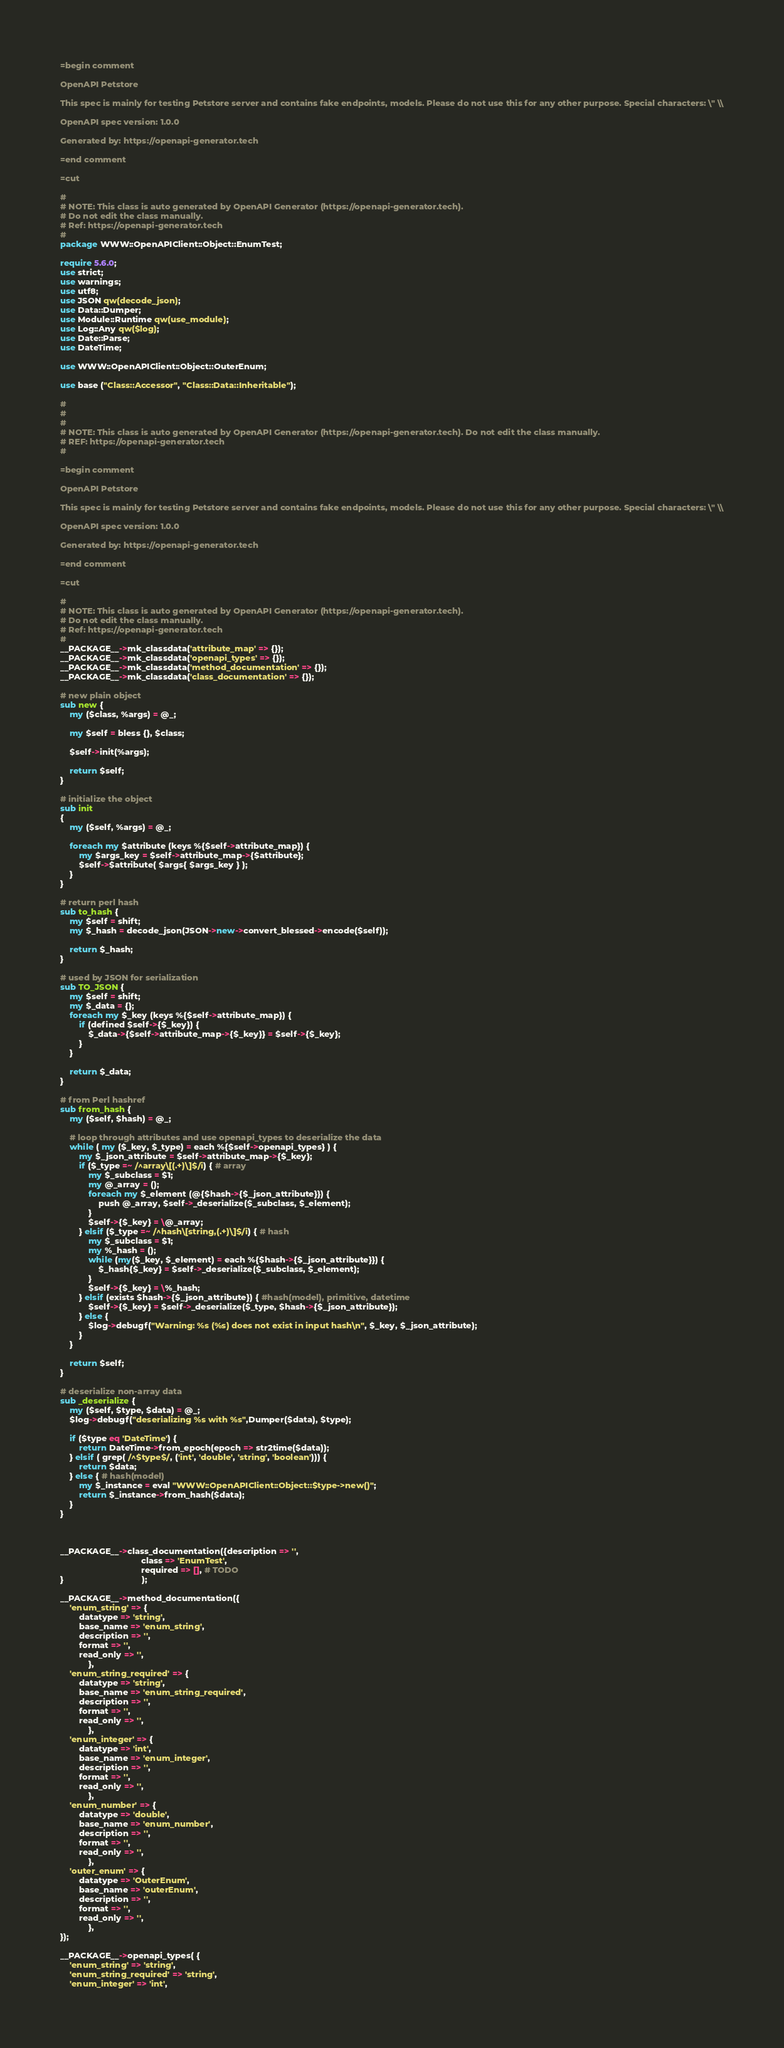Convert code to text. <code><loc_0><loc_0><loc_500><loc_500><_Perl_>=begin comment

OpenAPI Petstore

This spec is mainly for testing Petstore server and contains fake endpoints, models. Please do not use this for any other purpose. Special characters: \" \\

OpenAPI spec version: 1.0.0

Generated by: https://openapi-generator.tech

=end comment

=cut

#
# NOTE: This class is auto generated by OpenAPI Generator (https://openapi-generator.tech).
# Do not edit the class manually.
# Ref: https://openapi-generator.tech
#
package WWW::OpenAPIClient::Object::EnumTest;

require 5.6.0;
use strict;
use warnings;
use utf8;
use JSON qw(decode_json);
use Data::Dumper;
use Module::Runtime qw(use_module);
use Log::Any qw($log);
use Date::Parse;
use DateTime;

use WWW::OpenAPIClient::Object::OuterEnum;

use base ("Class::Accessor", "Class::Data::Inheritable");

#
#
#
# NOTE: This class is auto generated by OpenAPI Generator (https://openapi-generator.tech). Do not edit the class manually.
# REF: https://openapi-generator.tech
#

=begin comment

OpenAPI Petstore

This spec is mainly for testing Petstore server and contains fake endpoints, models. Please do not use this for any other purpose. Special characters: \" \\

OpenAPI spec version: 1.0.0

Generated by: https://openapi-generator.tech

=end comment

=cut

#
# NOTE: This class is auto generated by OpenAPI Generator (https://openapi-generator.tech).
# Do not edit the class manually.
# Ref: https://openapi-generator.tech
#
__PACKAGE__->mk_classdata('attribute_map' => {});
__PACKAGE__->mk_classdata('openapi_types' => {});
__PACKAGE__->mk_classdata('method_documentation' => {}); 
__PACKAGE__->mk_classdata('class_documentation' => {});

# new plain object
sub new { 
    my ($class, %args) = @_; 

    my $self = bless {}, $class;

    $self->init(%args);
    
    return $self;
}

# initialize the object
sub init
{
    my ($self, %args) = @_;

    foreach my $attribute (keys %{$self->attribute_map}) {
        my $args_key = $self->attribute_map->{$attribute};
        $self->$attribute( $args{ $args_key } );
    }
}

# return perl hash
sub to_hash {
    my $self = shift;
    my $_hash = decode_json(JSON->new->convert_blessed->encode($self));

    return $_hash;
}

# used by JSON for serialization
sub TO_JSON { 
    my $self = shift;
    my $_data = {};
    foreach my $_key (keys %{$self->attribute_map}) {
        if (defined $self->{$_key}) {
            $_data->{$self->attribute_map->{$_key}} = $self->{$_key};
        }
    }

    return $_data;
}

# from Perl hashref
sub from_hash {
    my ($self, $hash) = @_;

    # loop through attributes and use openapi_types to deserialize the data
    while ( my ($_key, $_type) = each %{$self->openapi_types} ) {
        my $_json_attribute = $self->attribute_map->{$_key}; 
        if ($_type =~ /^array\[(.+)\]$/i) { # array
            my $_subclass = $1;
            my @_array = ();
            foreach my $_element (@{$hash->{$_json_attribute}}) {
                push @_array, $self->_deserialize($_subclass, $_element);
            }
            $self->{$_key} = \@_array;
        } elsif ($_type =~ /^hash\[string,(.+)\]$/i) { # hash
            my $_subclass = $1;
            my %_hash = ();
            while (my($_key, $_element) = each %{$hash->{$_json_attribute}}) {
                $_hash{$_key} = $self->_deserialize($_subclass, $_element);
            }
            $self->{$_key} = \%_hash;
        } elsif (exists $hash->{$_json_attribute}) { #hash(model), primitive, datetime
            $self->{$_key} = $self->_deserialize($_type, $hash->{$_json_attribute});
        } else {
            $log->debugf("Warning: %s (%s) does not exist in input hash\n", $_key, $_json_attribute);
        }
    }
  
    return $self;
}

# deserialize non-array data
sub _deserialize {
    my ($self, $type, $data) = @_;
    $log->debugf("deserializing %s with %s",Dumper($data), $type);

    if ($type eq 'DateTime') {
        return DateTime->from_epoch(epoch => str2time($data));
    } elsif ( grep( /^$type$/, ('int', 'double', 'string', 'boolean'))) {
        return $data;
    } else { # hash(model)
        my $_instance = eval "WWW::OpenAPIClient::Object::$type->new()";
        return $_instance->from_hash($data);
    }
}



__PACKAGE__->class_documentation({description => '',
                                  class => 'EnumTest',
                                  required => [], # TODO
}                                 );

__PACKAGE__->method_documentation({
    'enum_string' => {
        datatype => 'string',
        base_name => 'enum_string',
        description => '',
        format => '',
        read_only => '',
            },
    'enum_string_required' => {
        datatype => 'string',
        base_name => 'enum_string_required',
        description => '',
        format => '',
        read_only => '',
            },
    'enum_integer' => {
        datatype => 'int',
        base_name => 'enum_integer',
        description => '',
        format => '',
        read_only => '',
            },
    'enum_number' => {
        datatype => 'double',
        base_name => 'enum_number',
        description => '',
        format => '',
        read_only => '',
            },
    'outer_enum' => {
        datatype => 'OuterEnum',
        base_name => 'outerEnum',
        description => '',
        format => '',
        read_only => '',
            },
});

__PACKAGE__->openapi_types( {
    'enum_string' => 'string',
    'enum_string_required' => 'string',
    'enum_integer' => 'int',</code> 